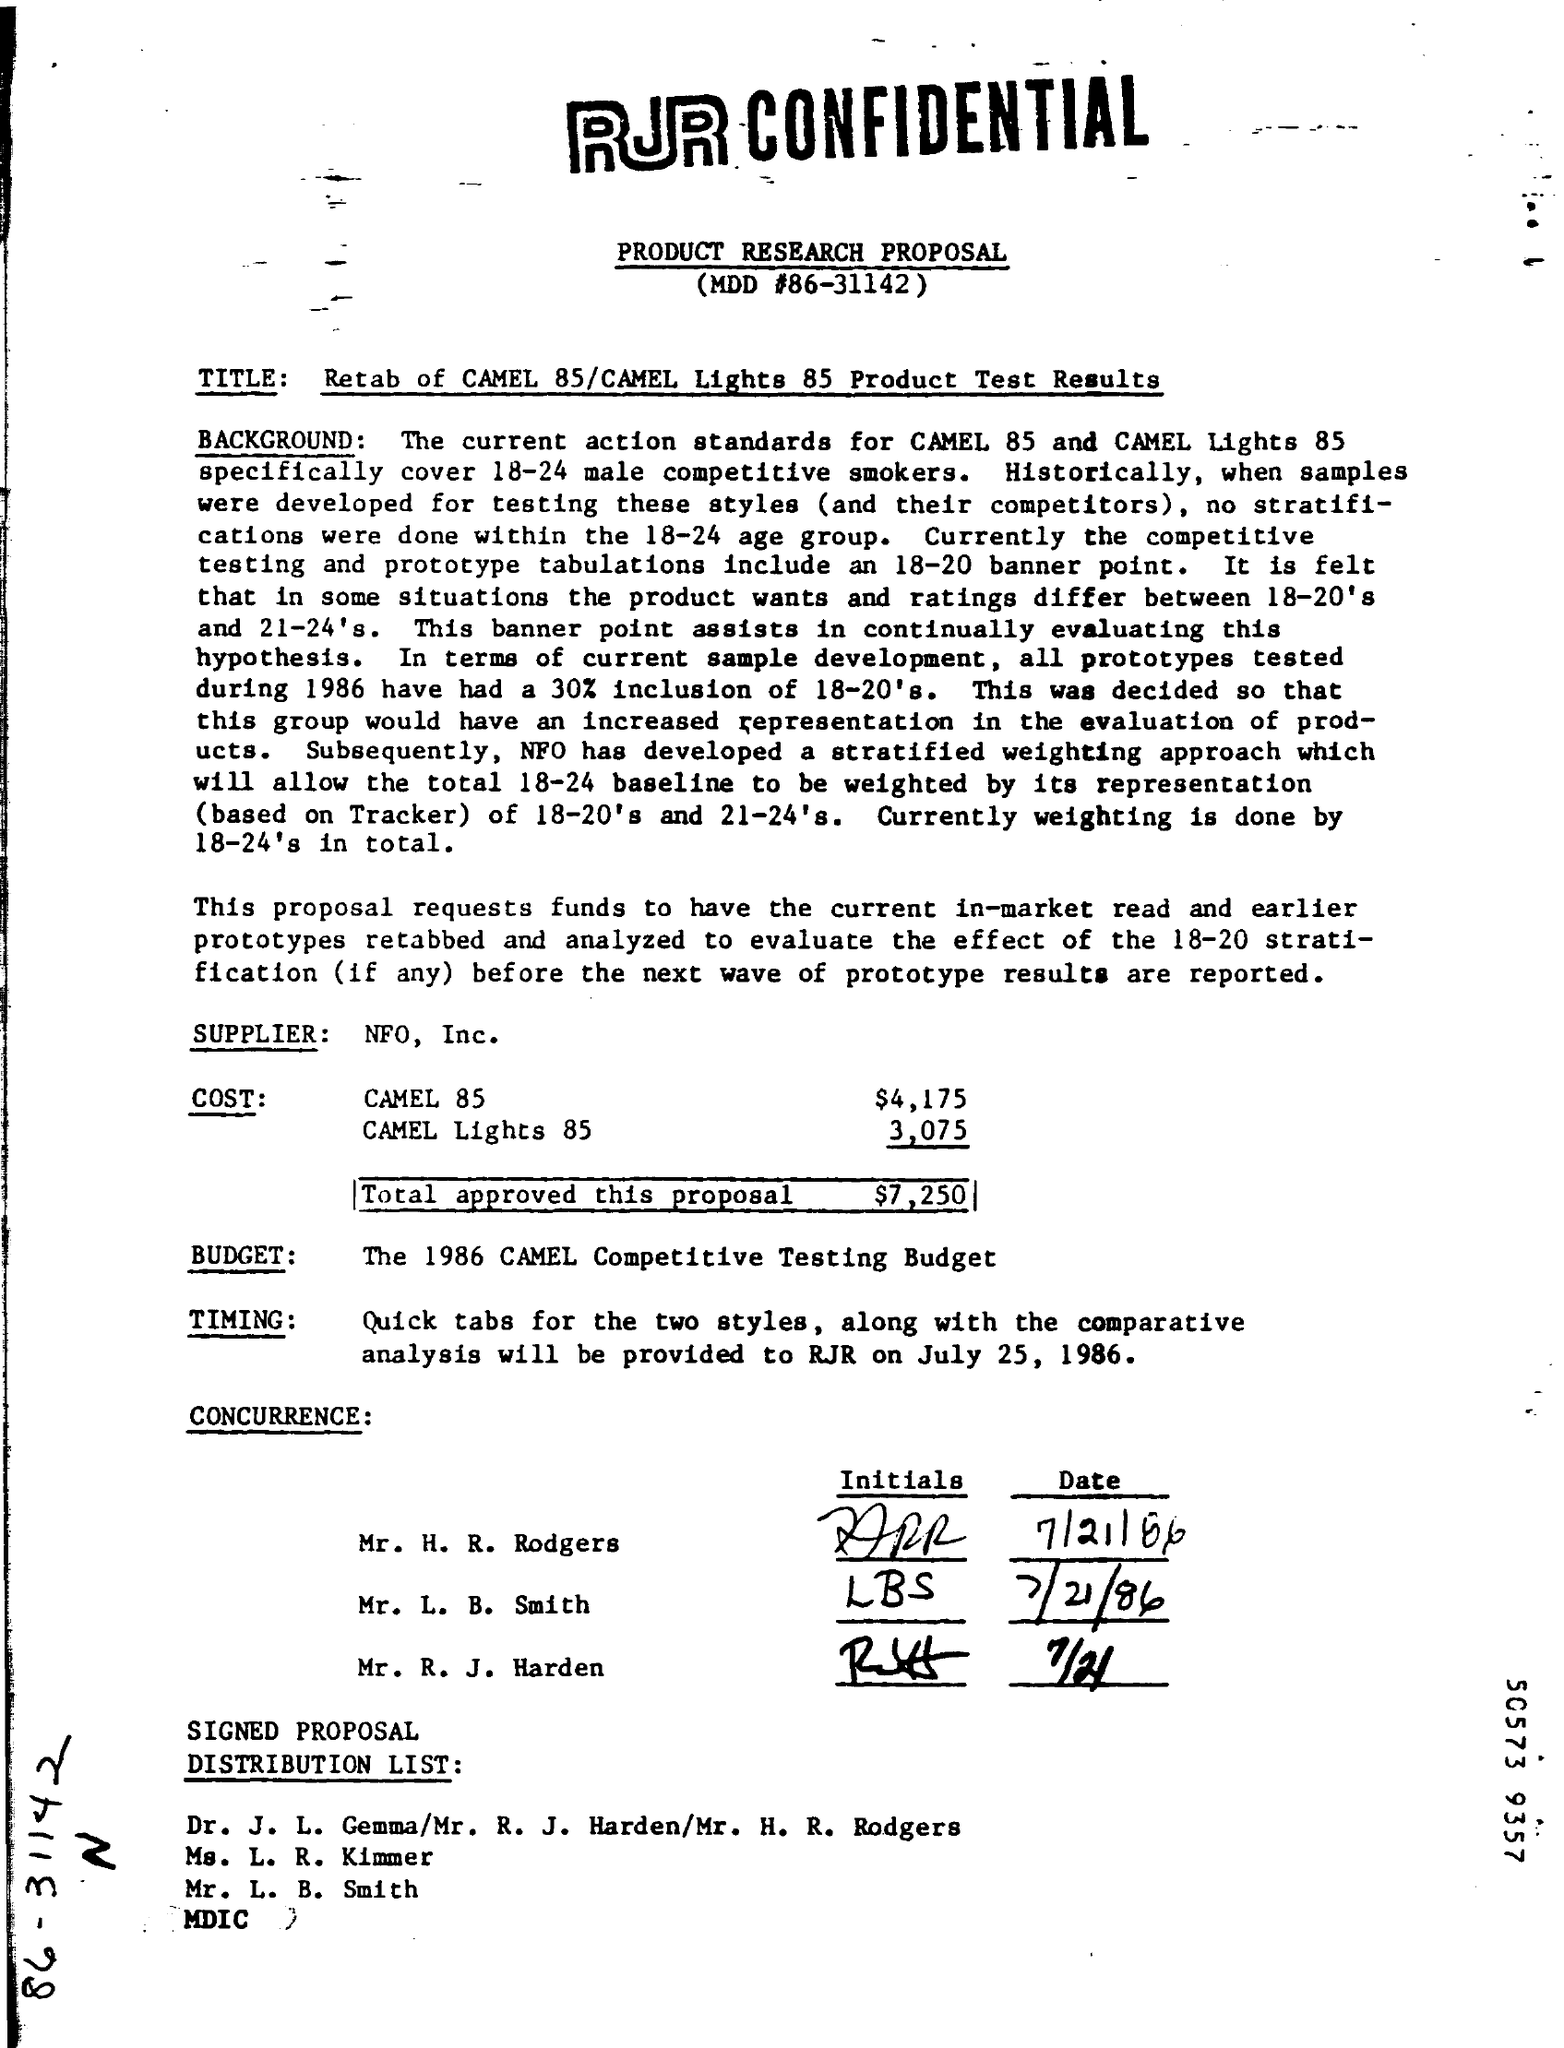What is the MDD #?
Your answer should be very brief. 86-31142. Who is the Supplier?
Your response must be concise. NFO, Inc. What is the Cost for Camel 85?
Give a very brief answer. $4,175. What is the Cost for Camel Lights 85?
Make the answer very short. 3,075. What is the Total approved for this proposal?
Make the answer very short. $7,250. 